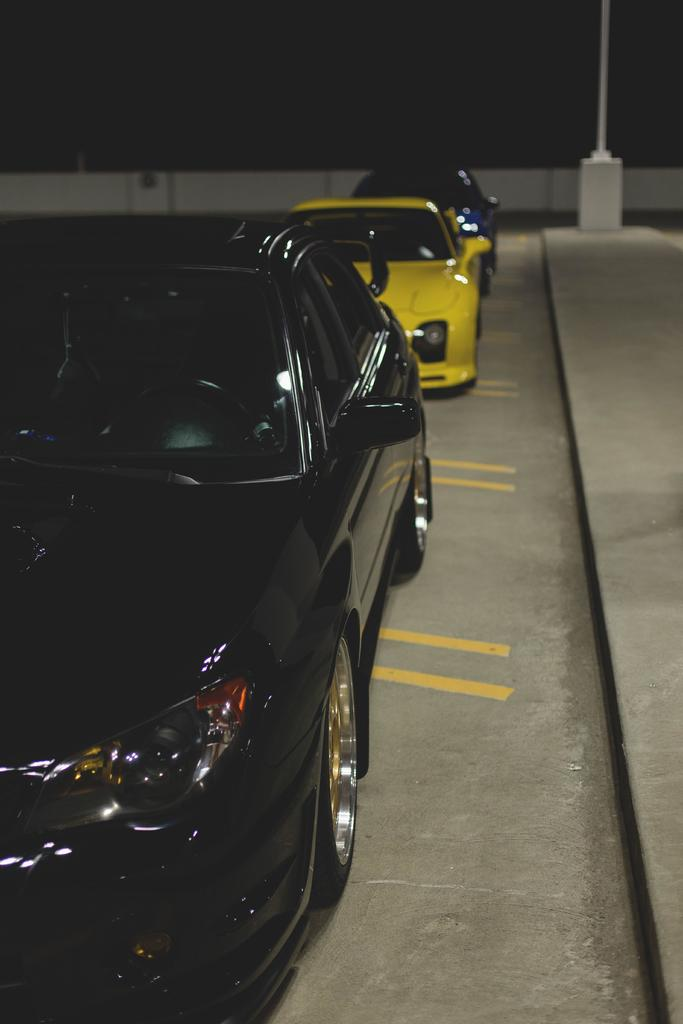How many cars are present in the image? There are three cars in the image. What colors are the cars in the image? One car is black, one car is yellow, and one car is blue. Where is the cave located in the image? There is no cave present in the image. What type of clothing is hanging from the swing in the image? There is no swing or clothing present in the image. 